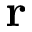<formula> <loc_0><loc_0><loc_500><loc_500>r</formula> 